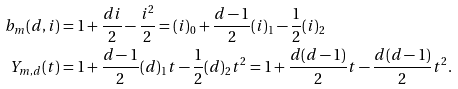<formula> <loc_0><loc_0><loc_500><loc_500>b _ { m } ( d , i ) & = 1 + \frac { d i } { 2 } - \frac { i ^ { 2 } } { 2 } = ( i ) _ { 0 } + \frac { d - 1 } { 2 } ( i ) _ { 1 } - \frac { 1 } { 2 } ( i ) _ { 2 } \\ Y _ { m , d } ( t ) & = 1 + \frac { d - 1 } { 2 } ( d ) _ { 1 } t - \frac { 1 } { 2 } ( d ) _ { 2 } t ^ { 2 } = 1 + \frac { d ( d - 1 ) } { 2 } t - \frac { d ( d - 1 ) } { 2 } t ^ { 2 } .</formula> 